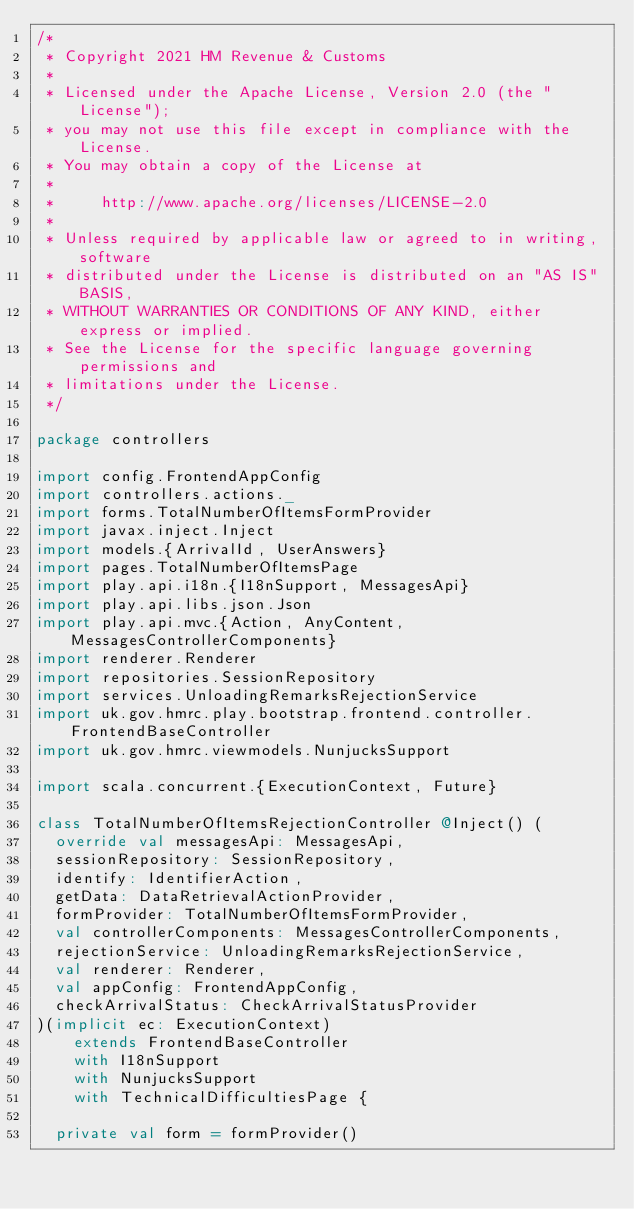<code> <loc_0><loc_0><loc_500><loc_500><_Scala_>/*
 * Copyright 2021 HM Revenue & Customs
 *
 * Licensed under the Apache License, Version 2.0 (the "License");
 * you may not use this file except in compliance with the License.
 * You may obtain a copy of the License at
 *
 *     http://www.apache.org/licenses/LICENSE-2.0
 *
 * Unless required by applicable law or agreed to in writing, software
 * distributed under the License is distributed on an "AS IS" BASIS,
 * WITHOUT WARRANTIES OR CONDITIONS OF ANY KIND, either express or implied.
 * See the License for the specific language governing permissions and
 * limitations under the License.
 */

package controllers

import config.FrontendAppConfig
import controllers.actions._
import forms.TotalNumberOfItemsFormProvider
import javax.inject.Inject
import models.{ArrivalId, UserAnswers}
import pages.TotalNumberOfItemsPage
import play.api.i18n.{I18nSupport, MessagesApi}
import play.api.libs.json.Json
import play.api.mvc.{Action, AnyContent, MessagesControllerComponents}
import renderer.Renderer
import repositories.SessionRepository
import services.UnloadingRemarksRejectionService
import uk.gov.hmrc.play.bootstrap.frontend.controller.FrontendBaseController
import uk.gov.hmrc.viewmodels.NunjucksSupport

import scala.concurrent.{ExecutionContext, Future}

class TotalNumberOfItemsRejectionController @Inject() (
  override val messagesApi: MessagesApi,
  sessionRepository: SessionRepository,
  identify: IdentifierAction,
  getData: DataRetrievalActionProvider,
  formProvider: TotalNumberOfItemsFormProvider,
  val controllerComponents: MessagesControllerComponents,
  rejectionService: UnloadingRemarksRejectionService,
  val renderer: Renderer,
  val appConfig: FrontendAppConfig,
  checkArrivalStatus: CheckArrivalStatusProvider
)(implicit ec: ExecutionContext)
    extends FrontendBaseController
    with I18nSupport
    with NunjucksSupport
    with TechnicalDifficultiesPage {

  private val form = formProvider()
</code> 